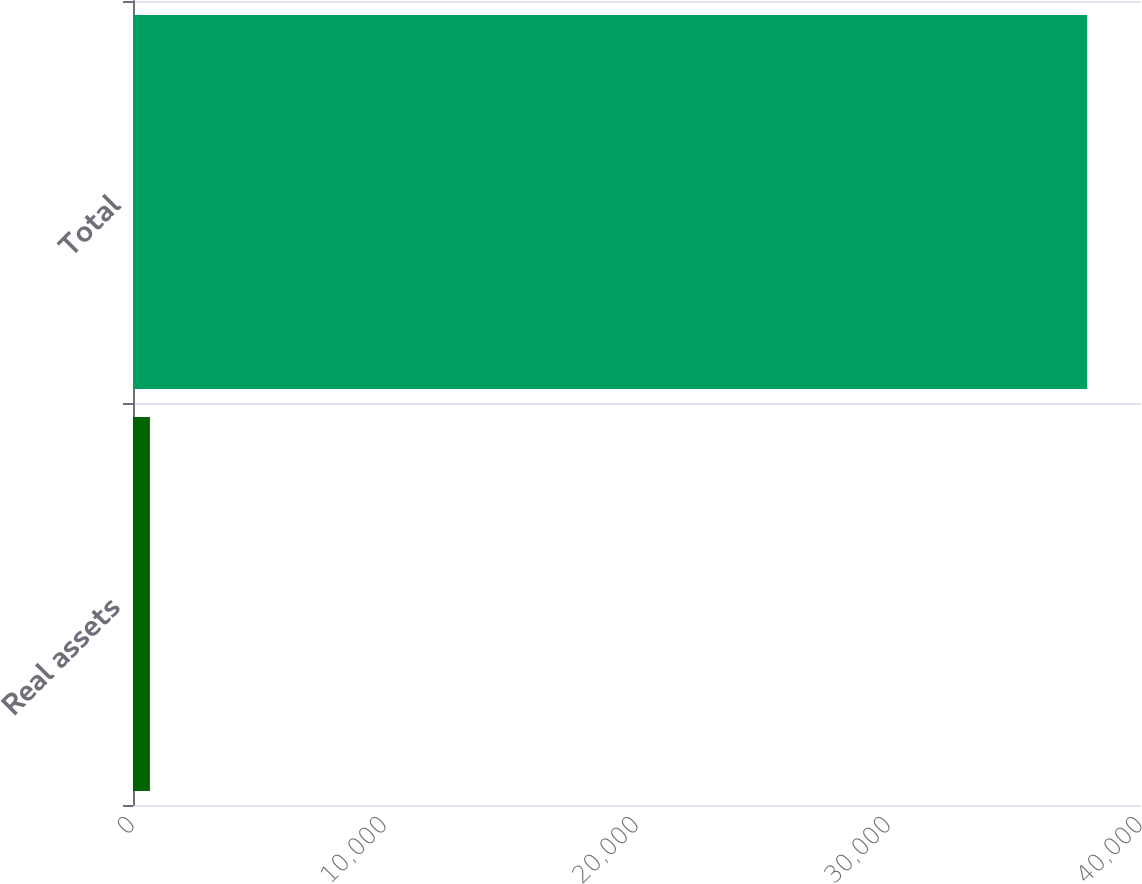<chart> <loc_0><loc_0><loc_500><loc_500><bar_chart><fcel>Real assets<fcel>Total<nl><fcel>672<fcel>37866<nl></chart> 